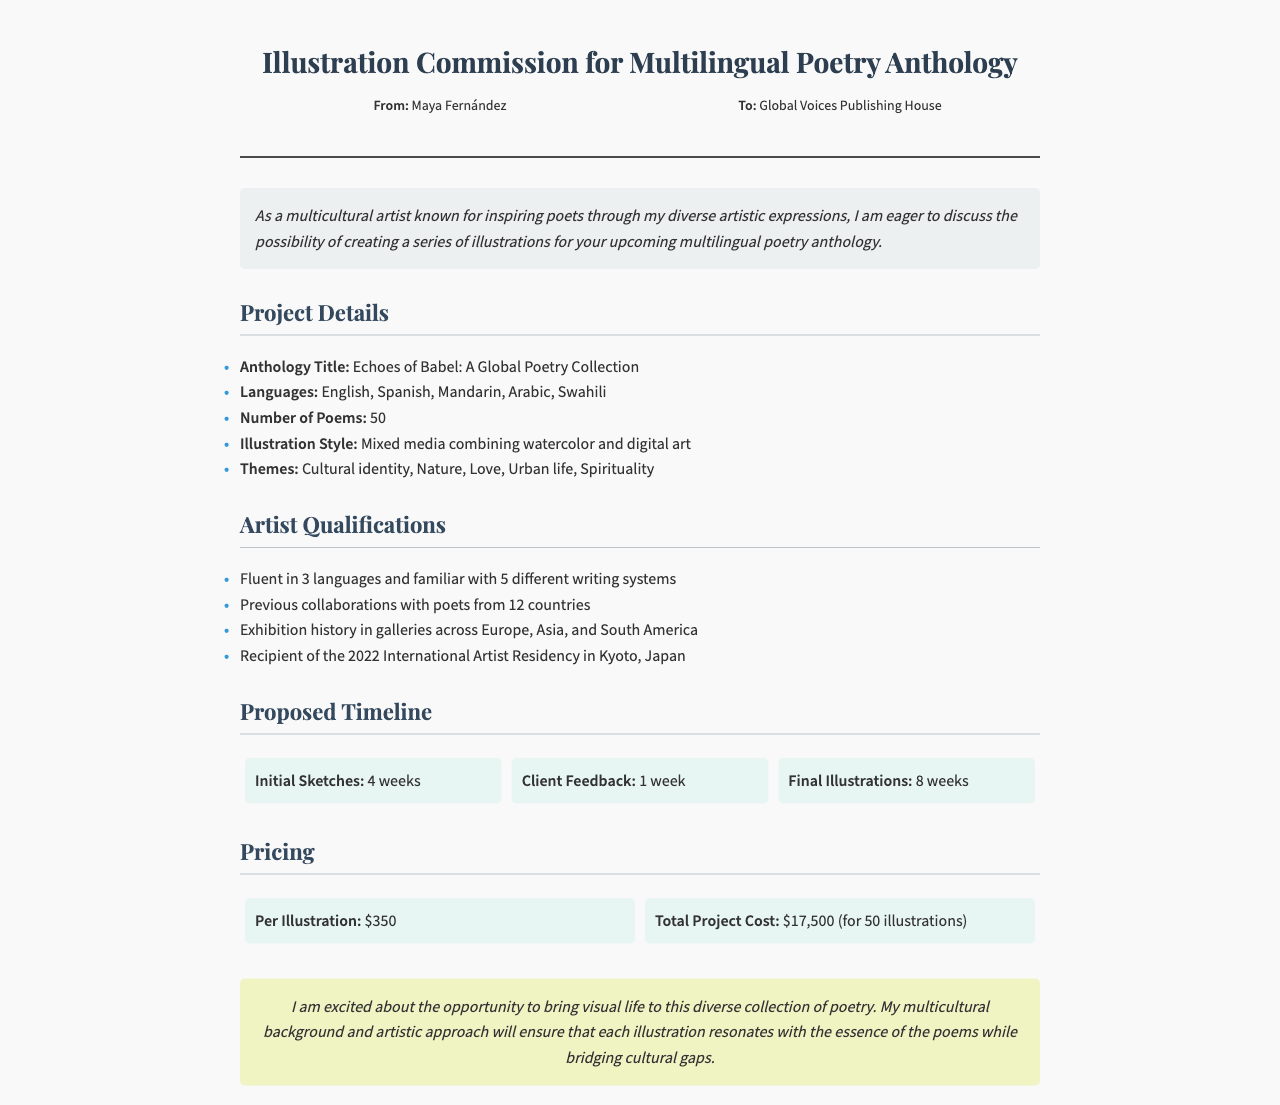What is the title of the anthology? The title of the anthology is mentioned in the project details section.
Answer: Echoes of Babel: A Global Poetry Collection How many languages will the anthology include? The number of languages is specified in the project details section.
Answer: 5 Who is the sender of the fax? The sender's name is given in the fax header.
Answer: Maya Fernández What is the total cost for the project? The total cost for the project is outlined in the pricing section.
Answer: $17,500 How many poems are included in the anthology? The number of poems is provided in the project details section.
Answer: 50 What is the illustration style proposed? The proposed illustration style is listed in the project details section.
Answer: Mixed media combining watercolor and digital art What are the first 4 weeks of the proposed timeline for? The initial part of the timeline refers to the early phase of the illustration process.
Answer: Initial Sketches What are the themes of the anthology? The themes are outlined in the project details section and consist of multiple elements.
Answer: Cultural identity, Nature, Love, Urban life, Spirituality What year was the artist awarded the residency? The specific year of the residency is mentioned in the artist qualifications section.
Answer: 2022 